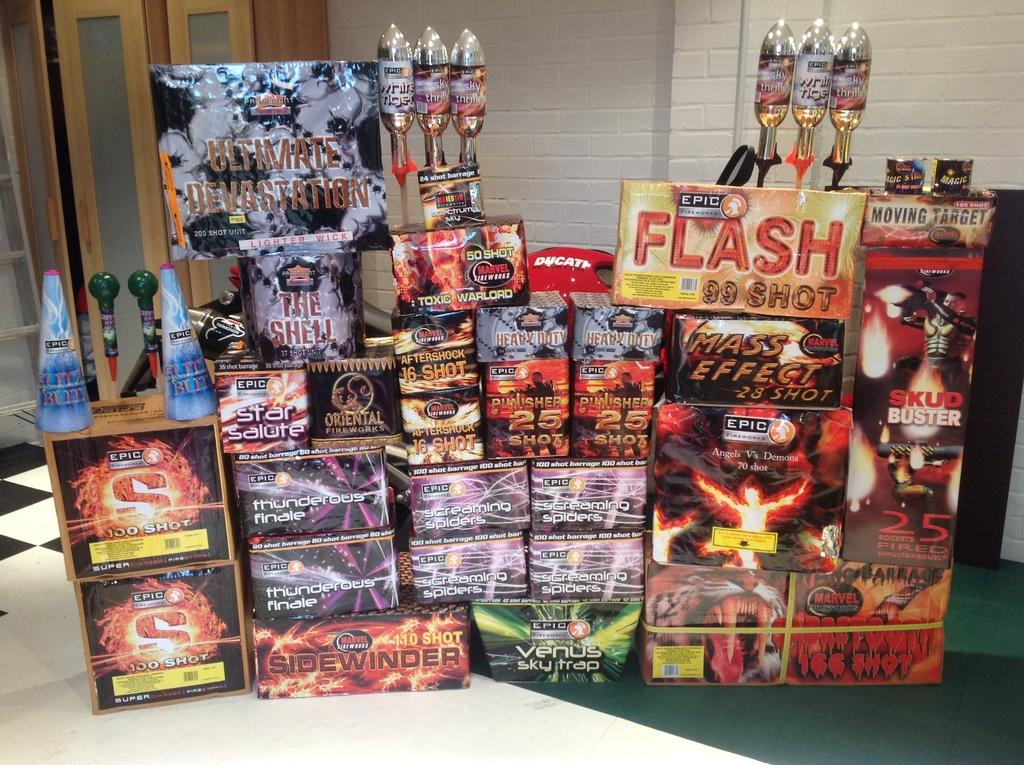<image>
Offer a succinct explanation of the picture presented. A display of stacked products advertises a product called Ultimate Devastation. 